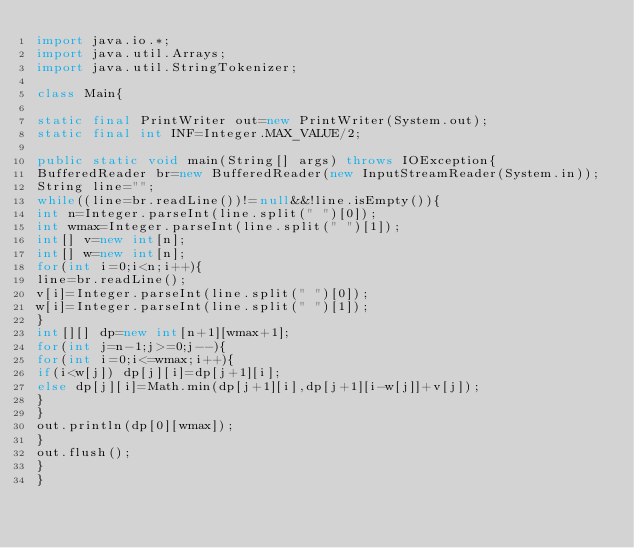<code> <loc_0><loc_0><loc_500><loc_500><_Java_>import java.io.*;
import java.util.Arrays;
import java.util.StringTokenizer;

class Main{

static final PrintWriter out=new PrintWriter(System.out);
static final int INF=Integer.MAX_VALUE/2;

public static void main(String[] args) throws IOException{
BufferedReader br=new BufferedReader(new InputStreamReader(System.in));
String line="";
while((line=br.readLine())!=null&&!line.isEmpty()){
int n=Integer.parseInt(line.split(" ")[0]);
int wmax=Integer.parseInt(line.split(" ")[1]);
int[] v=new int[n];
int[] w=new int[n];
for(int i=0;i<n;i++){
line=br.readLine();
v[i]=Integer.parseInt(line.split(" ")[0]);
w[i]=Integer.parseInt(line.split(" ")[1]);
}
int[][] dp=new int[n+1][wmax+1];
for(int j=n-1;j>=0;j--){
for(int i=0;i<=wmax;i++){
if(i<w[j]) dp[j][i]=dp[j+1][i];
else dp[j][i]=Math.min(dp[j+1][i],dp[j+1][i-w[j]]+v[j]);
}
}
out.println(dp[0][wmax]);
}
out.flush();
}
}</code> 